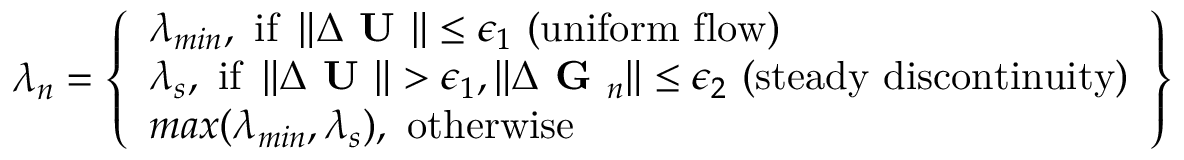Convert formula to latex. <formula><loc_0><loc_0><loc_500><loc_500>\lambda _ { n } = \left \{ \begin{array} { l } { \lambda _ { \min } , i f \left \| \Delta U \right \| \leq \epsilon _ { 1 } ( u n i f o r m f l o w ) } \\ { \lambda _ { s } , i f \left \| \Delta U \right \| > \epsilon _ { 1 } , \left \| \Delta G _ { n } \right \| \leq \epsilon _ { 2 } ( s t e a d y d i s c o n t i n u i t y ) } \\ { \max ( \lambda _ { \min } , \lambda _ { s } ) , o t h e r w i s e } \end{array} \right \}</formula> 